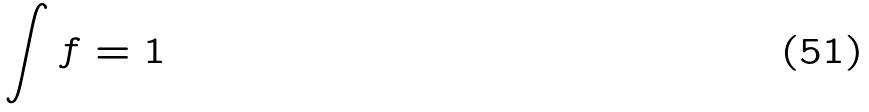Convert formula to latex. <formula><loc_0><loc_0><loc_500><loc_500>\int f = 1</formula> 